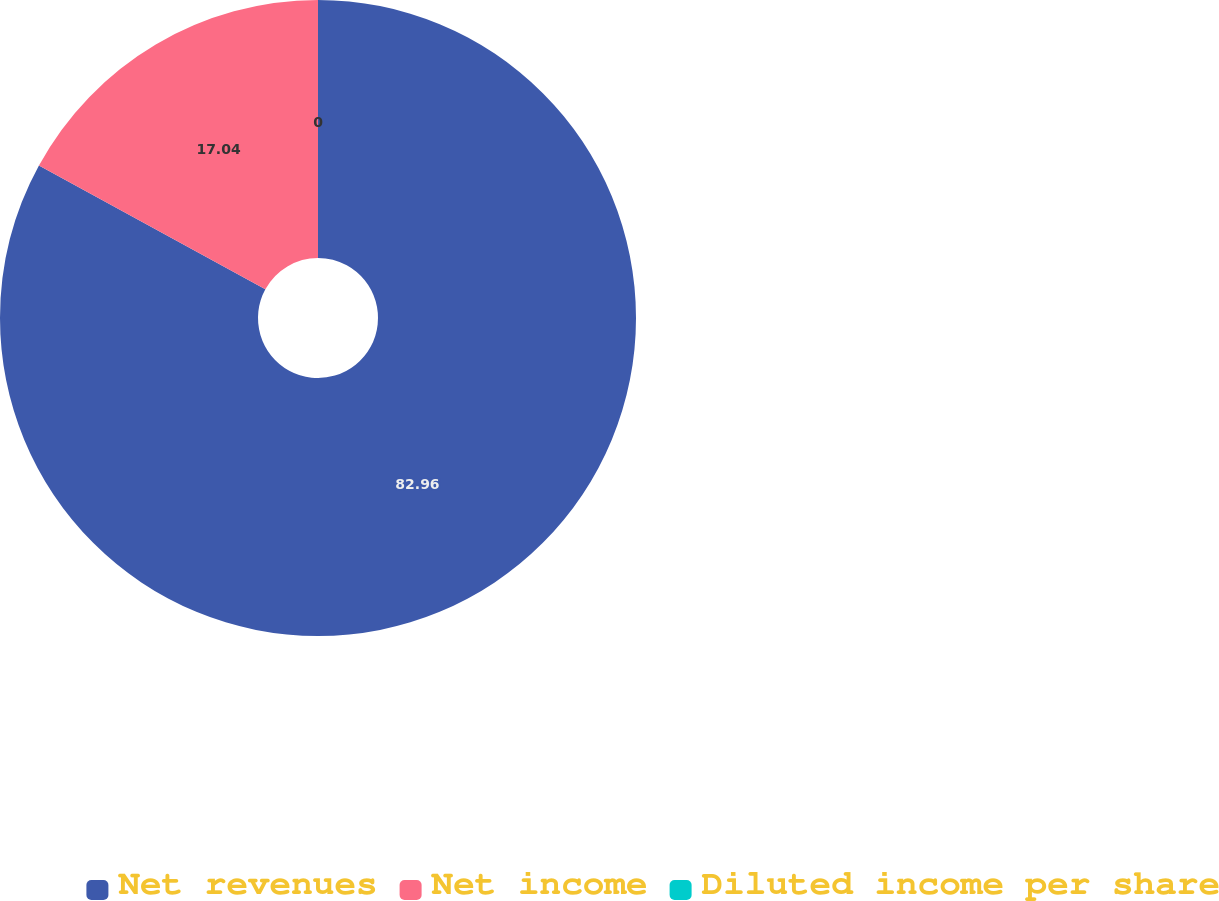Convert chart. <chart><loc_0><loc_0><loc_500><loc_500><pie_chart><fcel>Net revenues<fcel>Net income<fcel>Diluted income per share<nl><fcel>82.96%<fcel>17.04%<fcel>0.0%<nl></chart> 